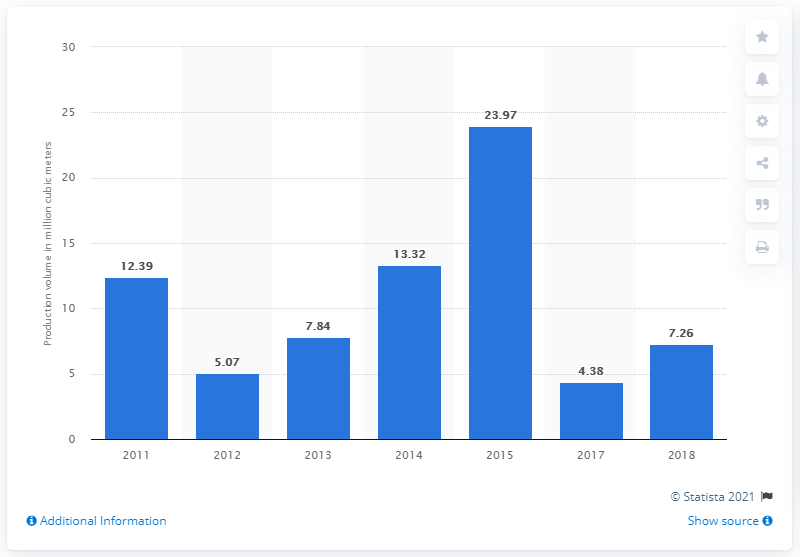Mention a couple of crucial points in this snapshot. In 2015, a total of 23.97 million cubic meters of limestone was produced in Indonesia. In 2018, the total volume of limestone produced in Indonesia was 7,260,000 metric tons. 